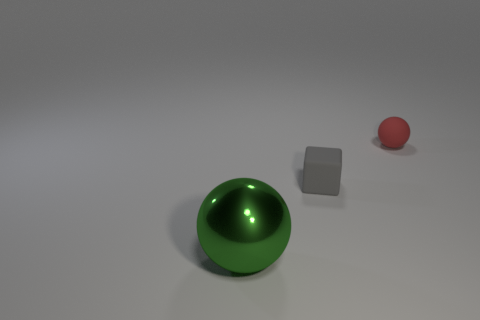Add 3 green metallic objects. How many objects exist? 6 Subtract all spheres. How many objects are left? 1 Subtract 1 balls. How many balls are left? 1 Add 2 large green cubes. How many large green cubes exist? 2 Subtract all red balls. How many balls are left? 1 Subtract 0 brown spheres. How many objects are left? 3 Subtract all gray spheres. Subtract all yellow cylinders. How many spheres are left? 2 Subtract all red rubber blocks. Subtract all cubes. How many objects are left? 2 Add 1 large green shiny objects. How many large green shiny objects are left? 2 